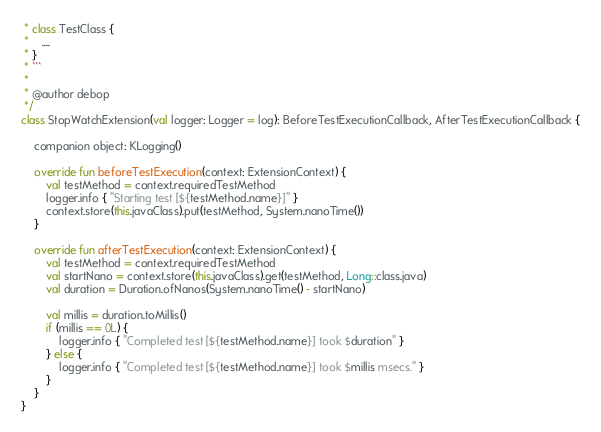<code> <loc_0><loc_0><loc_500><loc_500><_Kotlin_> * class TestClass {
 *    ....
 * }
 * ```
 *
 * @author debop
 */
class StopWatchExtension(val logger: Logger = log): BeforeTestExecutionCallback, AfterTestExecutionCallback {

    companion object: KLogging()

    override fun beforeTestExecution(context: ExtensionContext) {
        val testMethod = context.requiredTestMethod
        logger.info { "Starting test [${testMethod.name}]" }
        context.store(this.javaClass).put(testMethod, System.nanoTime())
    }

    override fun afterTestExecution(context: ExtensionContext) {
        val testMethod = context.requiredTestMethod
        val startNano = context.store(this.javaClass).get(testMethod, Long::class.java)
        val duration = Duration.ofNanos(System.nanoTime() - startNano)

        val millis = duration.toMillis()
        if (millis == 0L) {
            logger.info { "Completed test [${testMethod.name}] took $duration" }
        } else {
            logger.info { "Completed test [${testMethod.name}] took $millis msecs." }
        }
    }
}</code> 